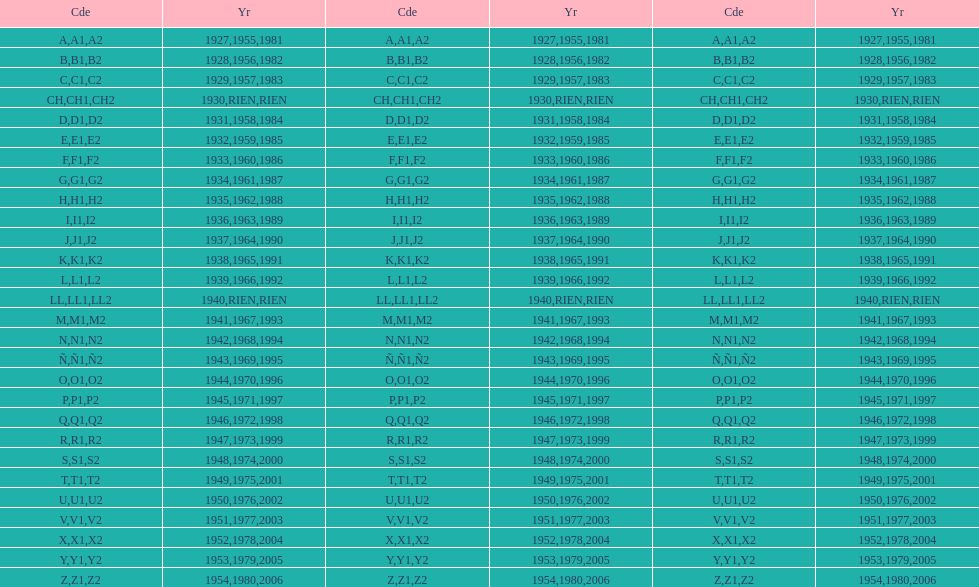Is the e code less than 1950? Yes. 